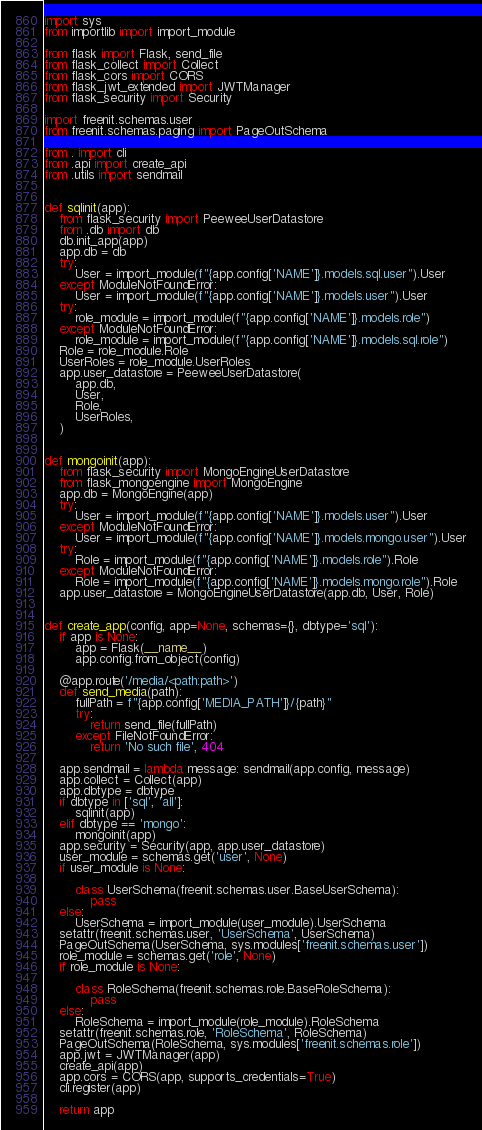<code> <loc_0><loc_0><loc_500><loc_500><_Python_>import sys
from importlib import import_module

from flask import Flask, send_file
from flask_collect import Collect
from flask_cors import CORS
from flask_jwt_extended import JWTManager
from flask_security import Security

import freenit.schemas.user
from freenit.schemas.paging import PageOutSchema

from . import cli
from .api import create_api
from .utils import sendmail


def sqlinit(app):
    from flask_security import PeeweeUserDatastore
    from .db import db
    db.init_app(app)
    app.db = db
    try:
        User = import_module(f"{app.config['NAME']}.models.sql.user").User
    except ModuleNotFoundError:
        User = import_module(f"{app.config['NAME']}.models.user").User
    try:
        role_module = import_module(f"{app.config['NAME']}.models.role")
    except ModuleNotFoundError:
        role_module = import_module(f"{app.config['NAME']}.models.sql.role")
    Role = role_module.Role
    UserRoles = role_module.UserRoles
    app.user_datastore = PeeweeUserDatastore(
        app.db,
        User,
        Role,
        UserRoles,
    )


def mongoinit(app):
    from flask_security import MongoEngineUserDatastore
    from flask_mongoengine import MongoEngine
    app.db = MongoEngine(app)
    try:
        User = import_module(f"{app.config['NAME']}.models.user").User
    except ModuleNotFoundError:
        User = import_module(f"{app.config['NAME']}.models.mongo.user").User
    try:
        Role = import_module(f"{app.config['NAME']}.models.role").Role
    except ModuleNotFoundError:
        Role = import_module(f"{app.config['NAME']}.models.mongo.role").Role
    app.user_datastore = MongoEngineUserDatastore(app.db, User, Role)


def create_app(config, app=None, schemas={}, dbtype='sql'):
    if app is None:
        app = Flask(__name__)
        app.config.from_object(config)

    @app.route('/media/<path:path>')
    def send_media(path):
        fullPath = f"{app.config['MEDIA_PATH']}/{path}"
        try:
            return send_file(fullPath)
        except FileNotFoundError:
            return 'No such file', 404

    app.sendmail = lambda message: sendmail(app.config, message)
    app.collect = Collect(app)
    app.dbtype = dbtype
    if dbtype in ['sql', 'all']:
        sqlinit(app)
    elif dbtype == 'mongo':
        mongoinit(app)
    app.security = Security(app, app.user_datastore)
    user_module = schemas.get('user', None)
    if user_module is None:

        class UserSchema(freenit.schemas.user.BaseUserSchema):
            pass
    else:
        UserSchema = import_module(user_module).UserSchema
    setattr(freenit.schemas.user, 'UserSchema', UserSchema)
    PageOutSchema(UserSchema, sys.modules['freenit.schemas.user'])
    role_module = schemas.get('role', None)
    if role_module is None:

        class RoleSchema(freenit.schemas.role.BaseRoleSchema):
            pass
    else:
        RoleSchema = import_module(role_module).RoleSchema
    setattr(freenit.schemas.role, 'RoleSchema', RoleSchema)
    PageOutSchema(RoleSchema, sys.modules['freenit.schemas.role'])
    app.jwt = JWTManager(app)
    create_api(app)
    app.cors = CORS(app, supports_credentials=True)
    cli.register(app)

    return app
</code> 